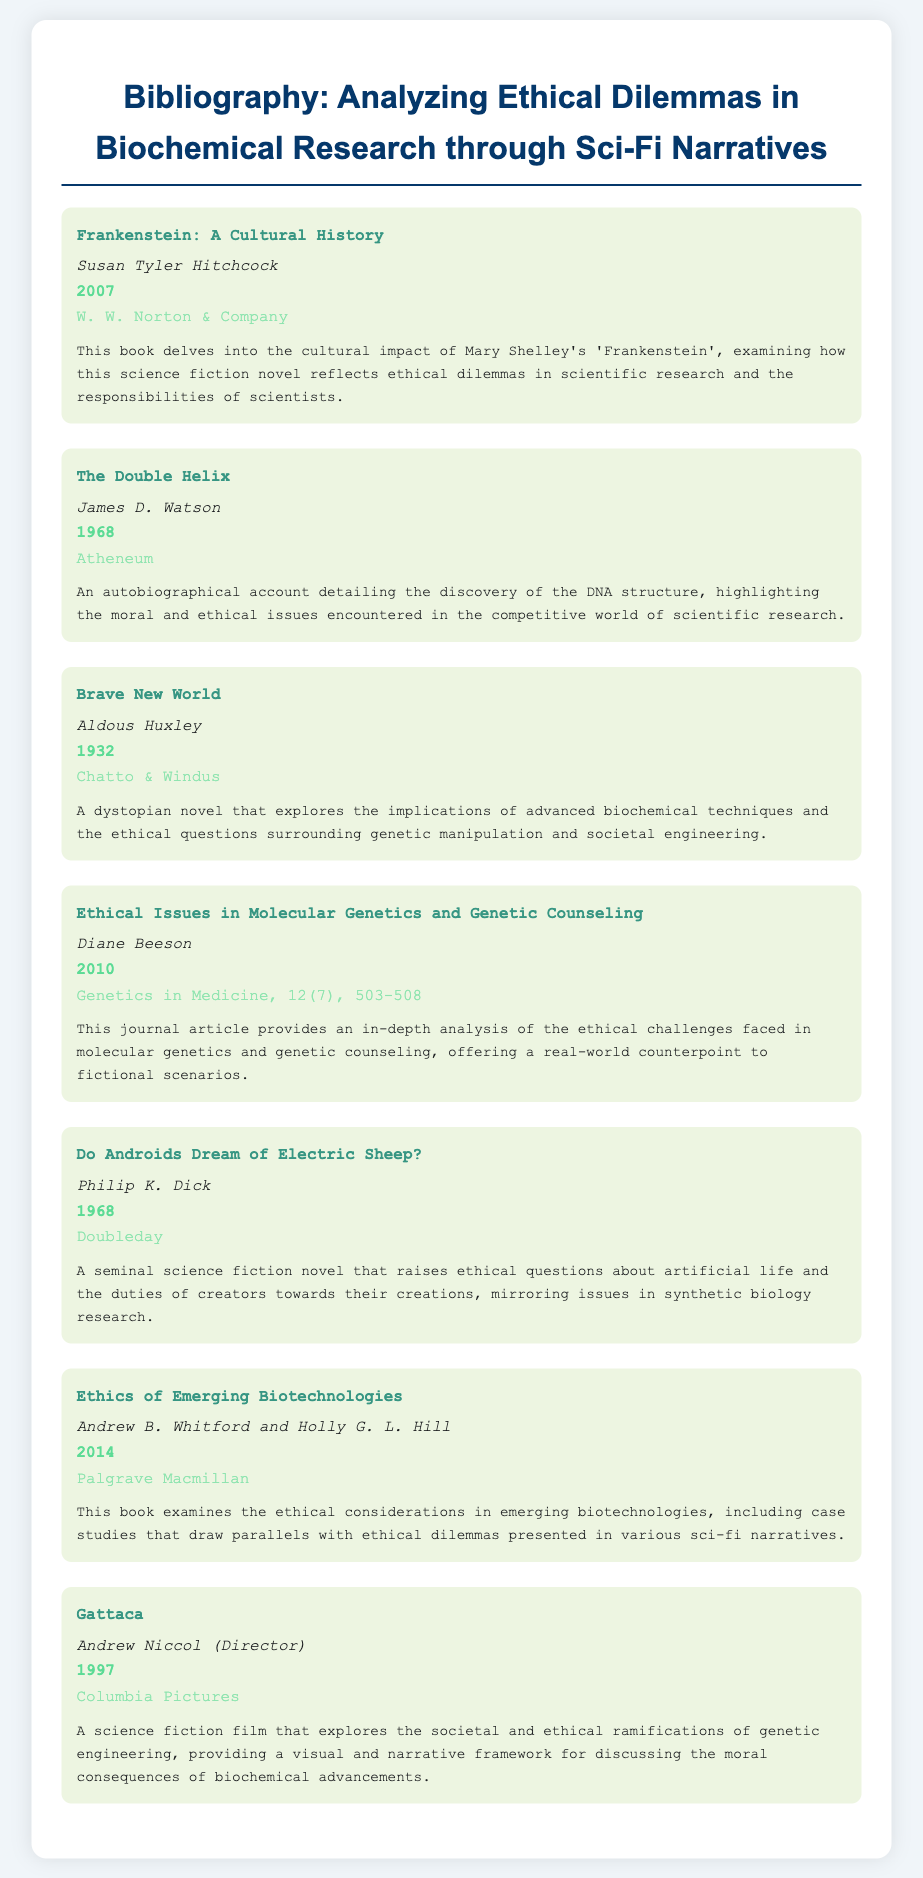What is the title of the first entry? The first entry is titled as indicated in the document, which is a specific title mentioned at the top of the entry.
Answer: Frankenstein: A Cultural History Who is the author of the book "Brave New World"? The author is a specific individual whose name is mentioned in the document, related to the publication of the book.
Answer: Aldous Huxley In which year was "The Double Helix" published? The year is explicitly stated in the entry for "The Double Helix," indicating when it was released.
Answer: 1968 What type of publication is "Ethics of Emerging Biotechnologies"? This is a specific type of publication identified within the document as a type of book.
Answer: Book Which work discusses artificial life and its ethical implications? This work is directly referenced in the document as exploring the ethics surrounding artificial creations.
Answer: Do Androids Dream of Electric Sheep? What is a common theme across the entries in this document? The common theme relates to ethical dilemmas, which is indicated as a consistent topic among the works listed.
Answer: Ethical dilemmas Which entry is authored by James D. Watson? The entry for a specific title mentions the author's name in the context of a memoir related to a significant scientific discovery.
Answer: The Double Helix What is the primary focus of "Gattaca"? The primary focus is directly described within the entry as dealing with the ramifications of a scientific concept.
Answer: Genetic engineering 